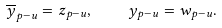Convert formula to latex. <formula><loc_0><loc_0><loc_500><loc_500>\overline { y } _ { p - u } = z _ { p - u } , \quad y _ { p - u } = w _ { p - u } .</formula> 